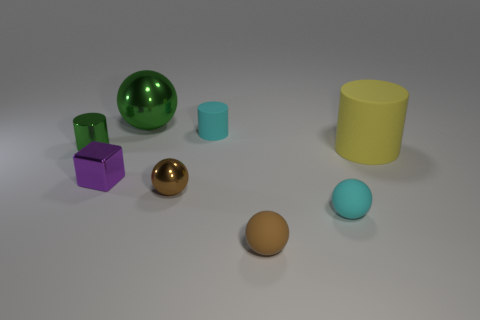Is there any other thing that has the same size as the cyan cylinder?
Your response must be concise. Yes. What size is the rubber ball that is the same color as the tiny metallic ball?
Make the answer very short. Small. Is there anything else that has the same material as the big cylinder?
Offer a very short reply. Yes. There is a large green metallic object; what shape is it?
Your answer should be compact. Sphere. What is the shape of the green metal thing to the left of the metallic ball to the left of the brown shiny thing?
Your response must be concise. Cylinder. Do the small green object that is to the left of the big metal object and the small purple cube have the same material?
Your answer should be compact. Yes. How many cyan things are small rubber spheres or large rubber cylinders?
Provide a succinct answer. 1. Are there any metal balls that have the same color as the shiny cylinder?
Keep it short and to the point. Yes. Are there any red things made of the same material as the big yellow thing?
Give a very brief answer. No. What shape is the tiny object that is both behind the purple metal thing and to the right of the brown shiny object?
Provide a short and direct response. Cylinder. 